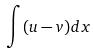<formula> <loc_0><loc_0><loc_500><loc_500>\int ( u - v ) d x</formula> 